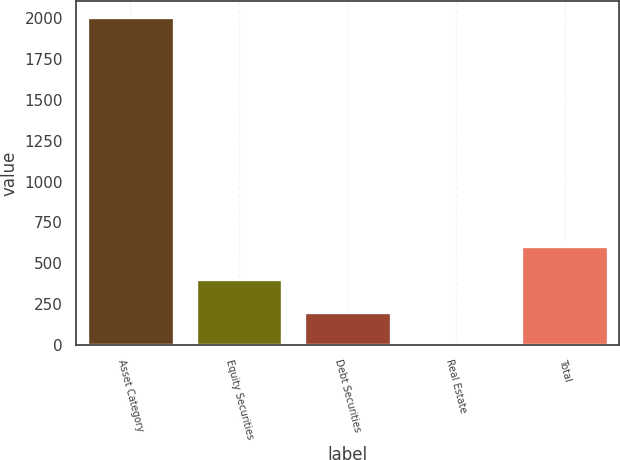Convert chart. <chart><loc_0><loc_0><loc_500><loc_500><bar_chart><fcel>Asset Category<fcel>Equity Securities<fcel>Debt Securities<fcel>Real Estate<fcel>Total<nl><fcel>2005<fcel>405<fcel>205<fcel>5<fcel>605<nl></chart> 